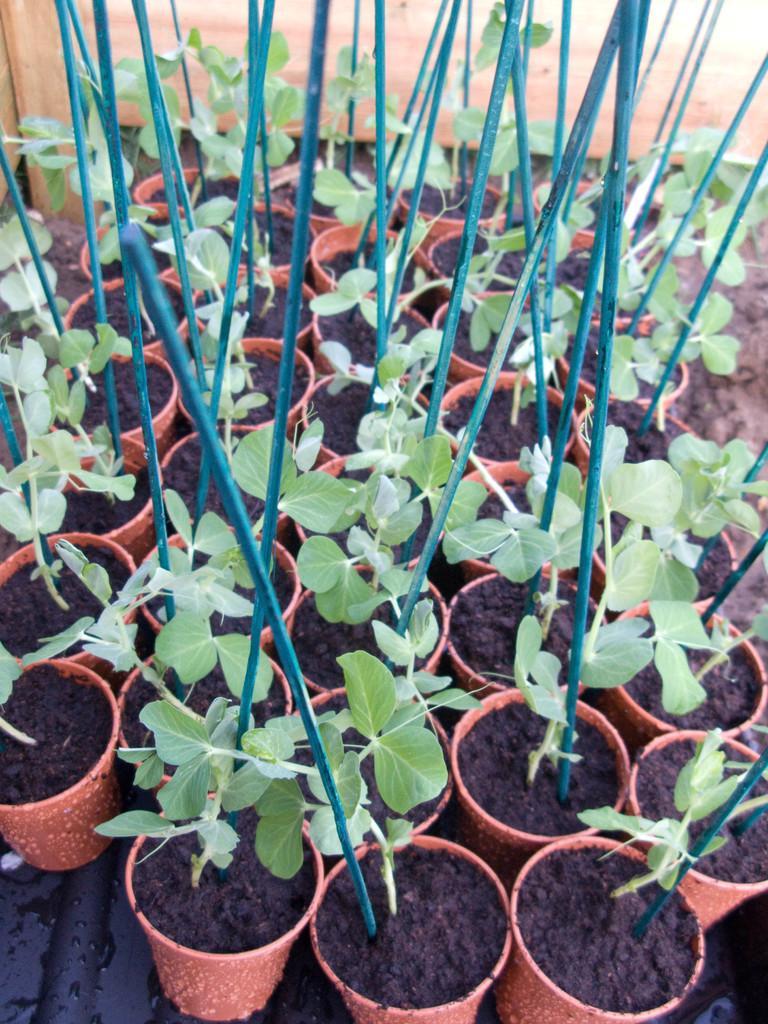Could you give a brief overview of what you see in this image? In this image we can see some potted plants and in the pots it looks like the rods. 